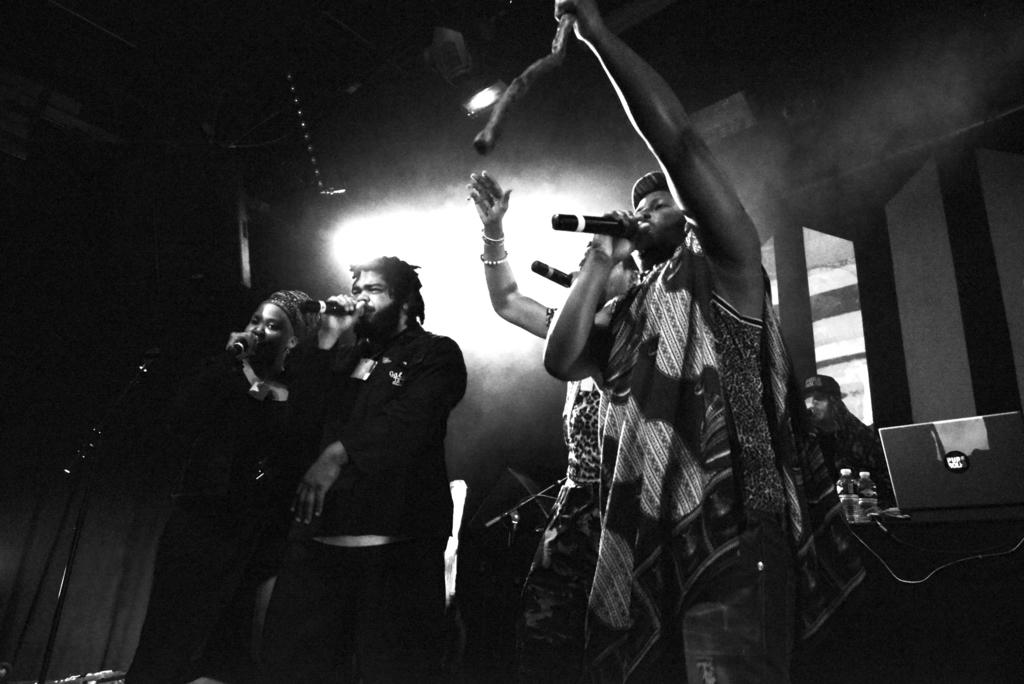What is the color scheme of the image? The image is black and white. What are the persons in the image doing? The persons are holding microphones and singing. What is present on the table in the image? There are bottles and a laptop on the table. What type of religion is being practiced by the beggar in the image? There is no beggar present in the image, and therefore no religious practice can be observed. Who is the expert in the image? There is no expert present in the image; the persons in the image are singing and holding microphones. 